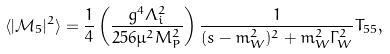<formula> <loc_0><loc_0><loc_500><loc_500>\langle | \mathcal { M } _ { 5 } | ^ { 2 } \rangle = \frac { 1 } { 4 } \left ( \frac { g ^ { 4 } \Lambda _ { i } ^ { 2 } } { 2 5 6 \mu ^ { 2 } M _ { P } ^ { 2 } } \right ) \frac { 1 } { ( s - m _ { W } ^ { 2 } ) ^ { 2 } + m _ { W } ^ { 2 } \Gamma _ { W } ^ { 2 } } { T } _ { 5 5 } ,</formula> 